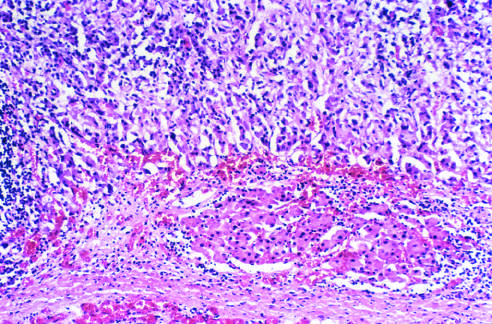does an infarct in the brain dwarf the kidney and compresse the upper pole?
Answer the question using a single word or phrase. No 